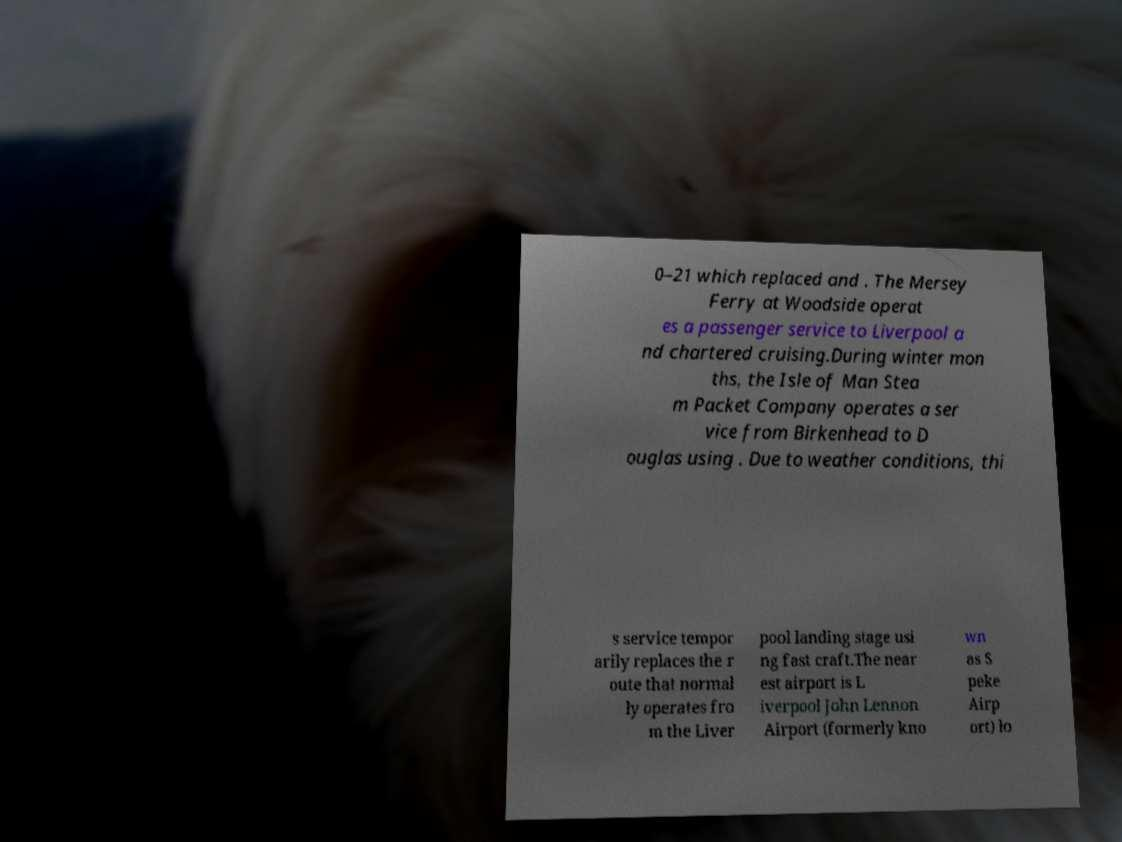There's text embedded in this image that I need extracted. Can you transcribe it verbatim? 0–21 which replaced and . The Mersey Ferry at Woodside operat es a passenger service to Liverpool a nd chartered cruising.During winter mon ths, the Isle of Man Stea m Packet Company operates a ser vice from Birkenhead to D ouglas using . Due to weather conditions, thi s service tempor arily replaces the r oute that normal ly operates fro m the Liver pool landing stage usi ng fast craft.The near est airport is L iverpool John Lennon Airport (formerly kno wn as S peke Airp ort) lo 